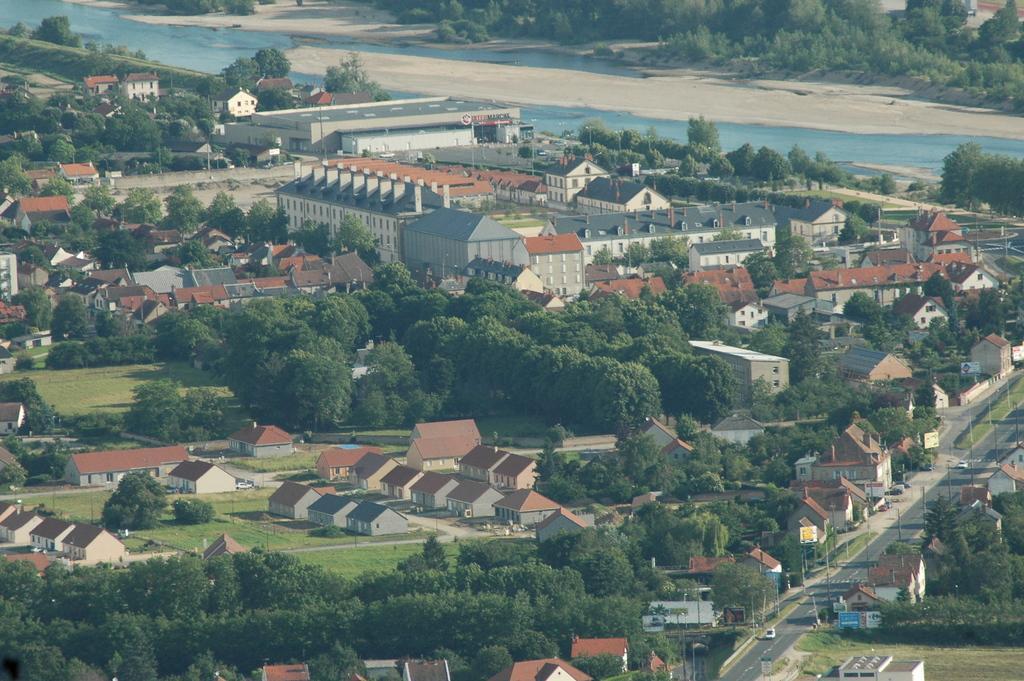Describe this image in one or two sentences. In the picture we can see an Ariel view of the surface with many houses, buildings, factories, grass surfaces and on it we can see the trees and we can see some trees in the middle of the houses and we can also see the road and in the background we can see a canal with blue color water and behind it we can see plants and trees. 